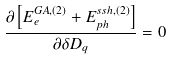<formula> <loc_0><loc_0><loc_500><loc_500>\frac { \partial \left [ E _ { e } ^ { G A , ( 2 ) } + E _ { p h } ^ { s s h , ( 2 ) } \right ] } { \partial \delta D _ { q } } = 0</formula> 